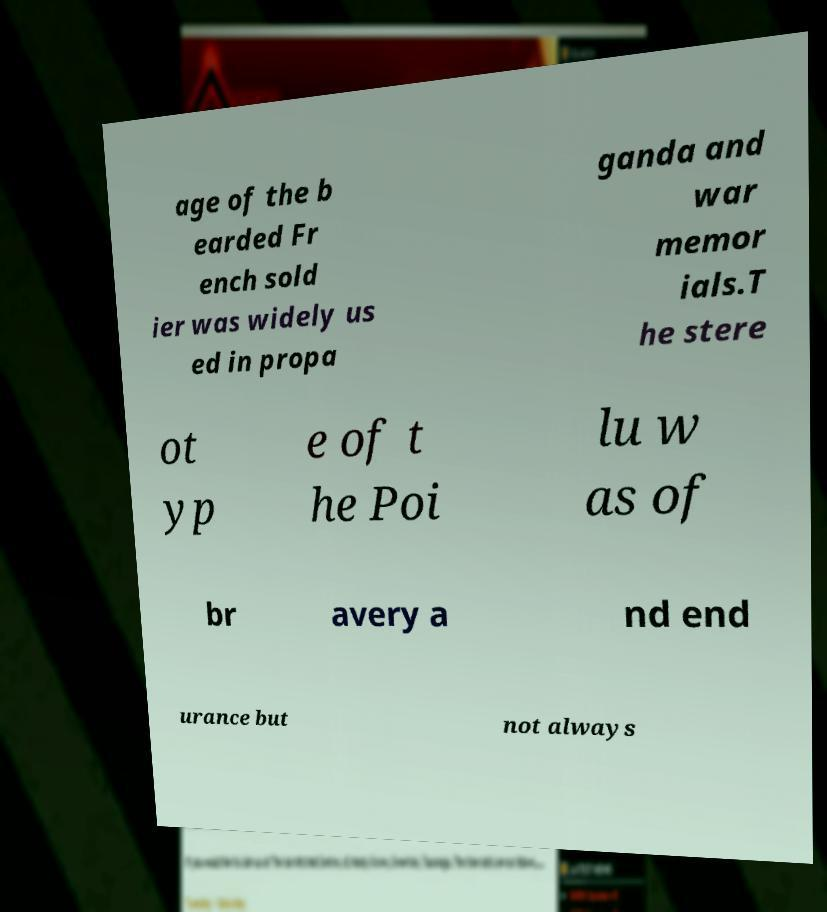For documentation purposes, I need the text within this image transcribed. Could you provide that? age of the b earded Fr ench sold ier was widely us ed in propa ganda and war memor ials.T he stere ot yp e of t he Poi lu w as of br avery a nd end urance but not always 